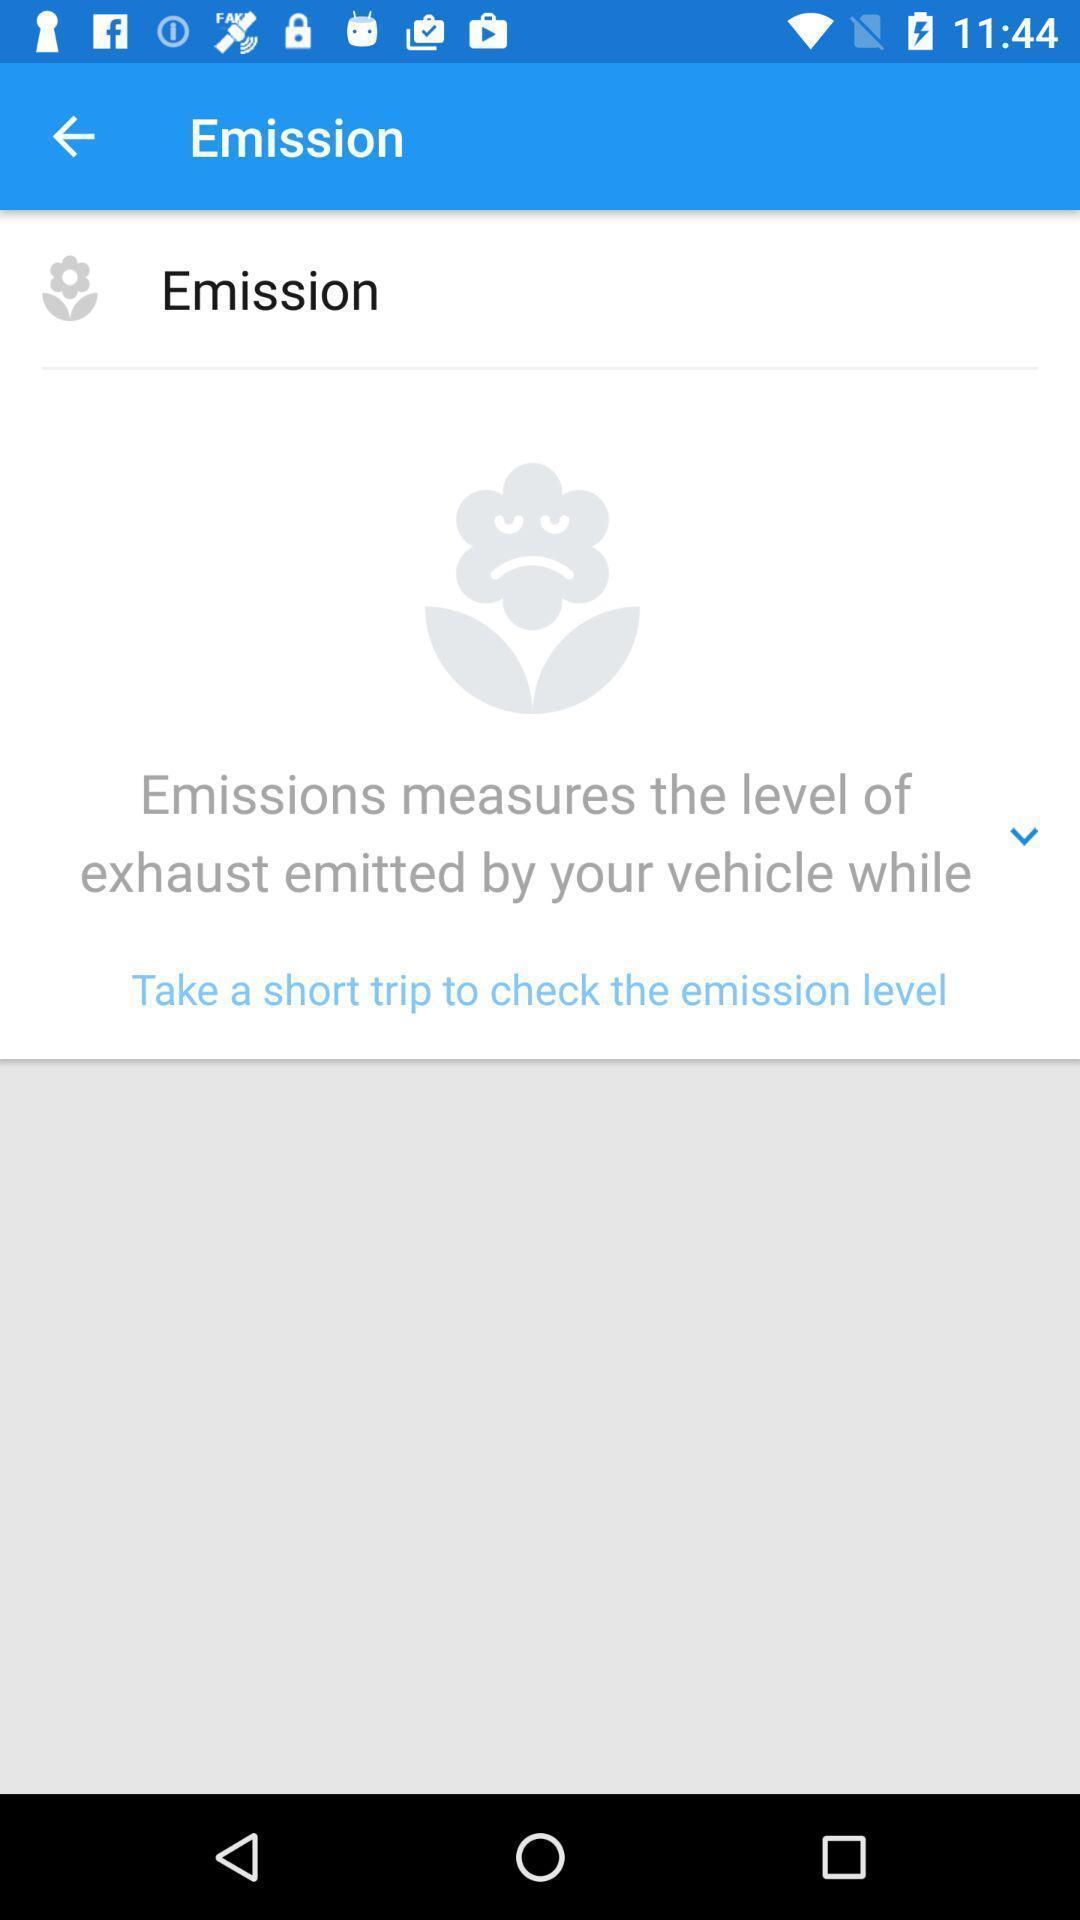What details can you identify in this image? Screen displaying the emission page. 